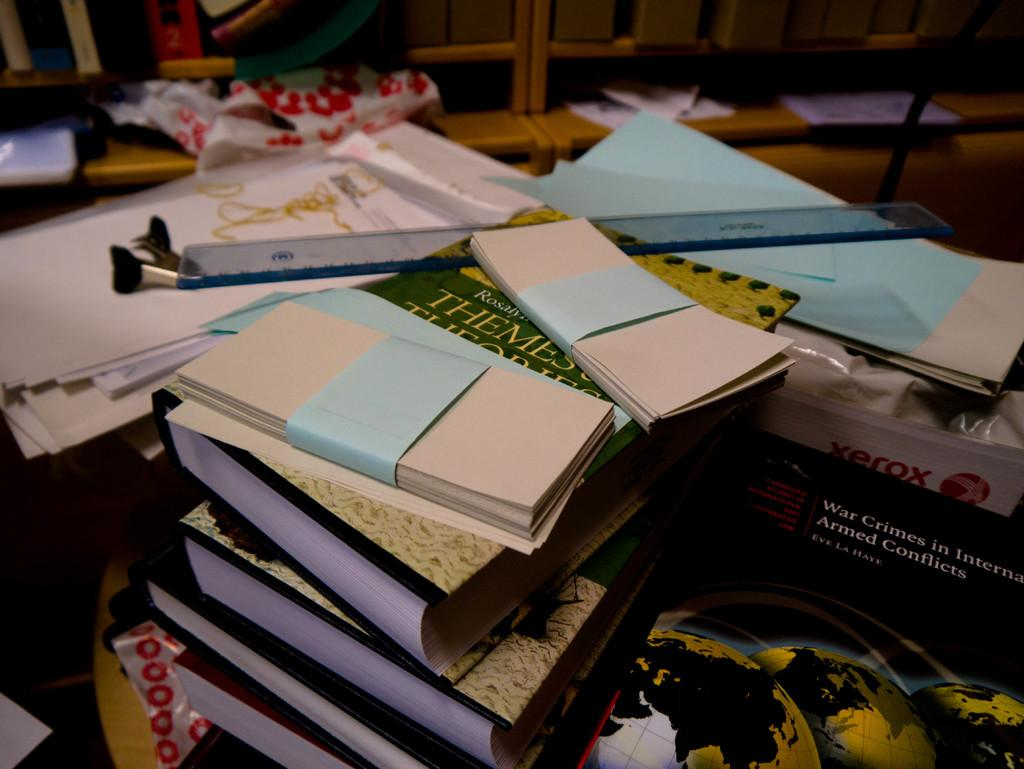<image>
Render a clear and concise summary of the photo. A stack of important books and papers on a table with a book called War Crimes in International Armed Conflicts holding up the stack on the right. 